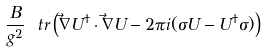<formula> <loc_0><loc_0><loc_500><loc_500>\frac { B } { g ^ { 2 } } \ t r \left ( \vec { \nabla } U ^ { \dagger } \cdot \vec { \nabla } U - 2 \pi i ( \sigma U - U ^ { \dagger } \sigma ) \right )</formula> 